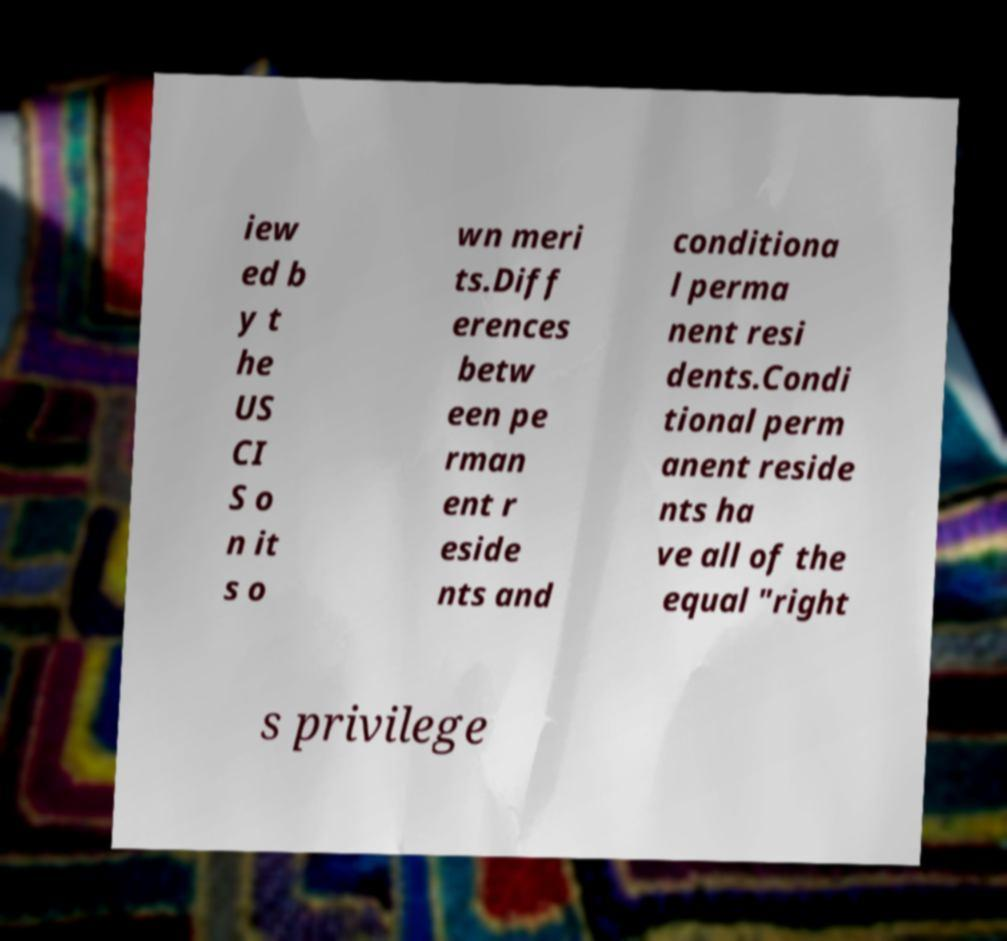There's text embedded in this image that I need extracted. Can you transcribe it verbatim? iew ed b y t he US CI S o n it s o wn meri ts.Diff erences betw een pe rman ent r eside nts and conditiona l perma nent resi dents.Condi tional perm anent reside nts ha ve all of the equal "right s privilege 